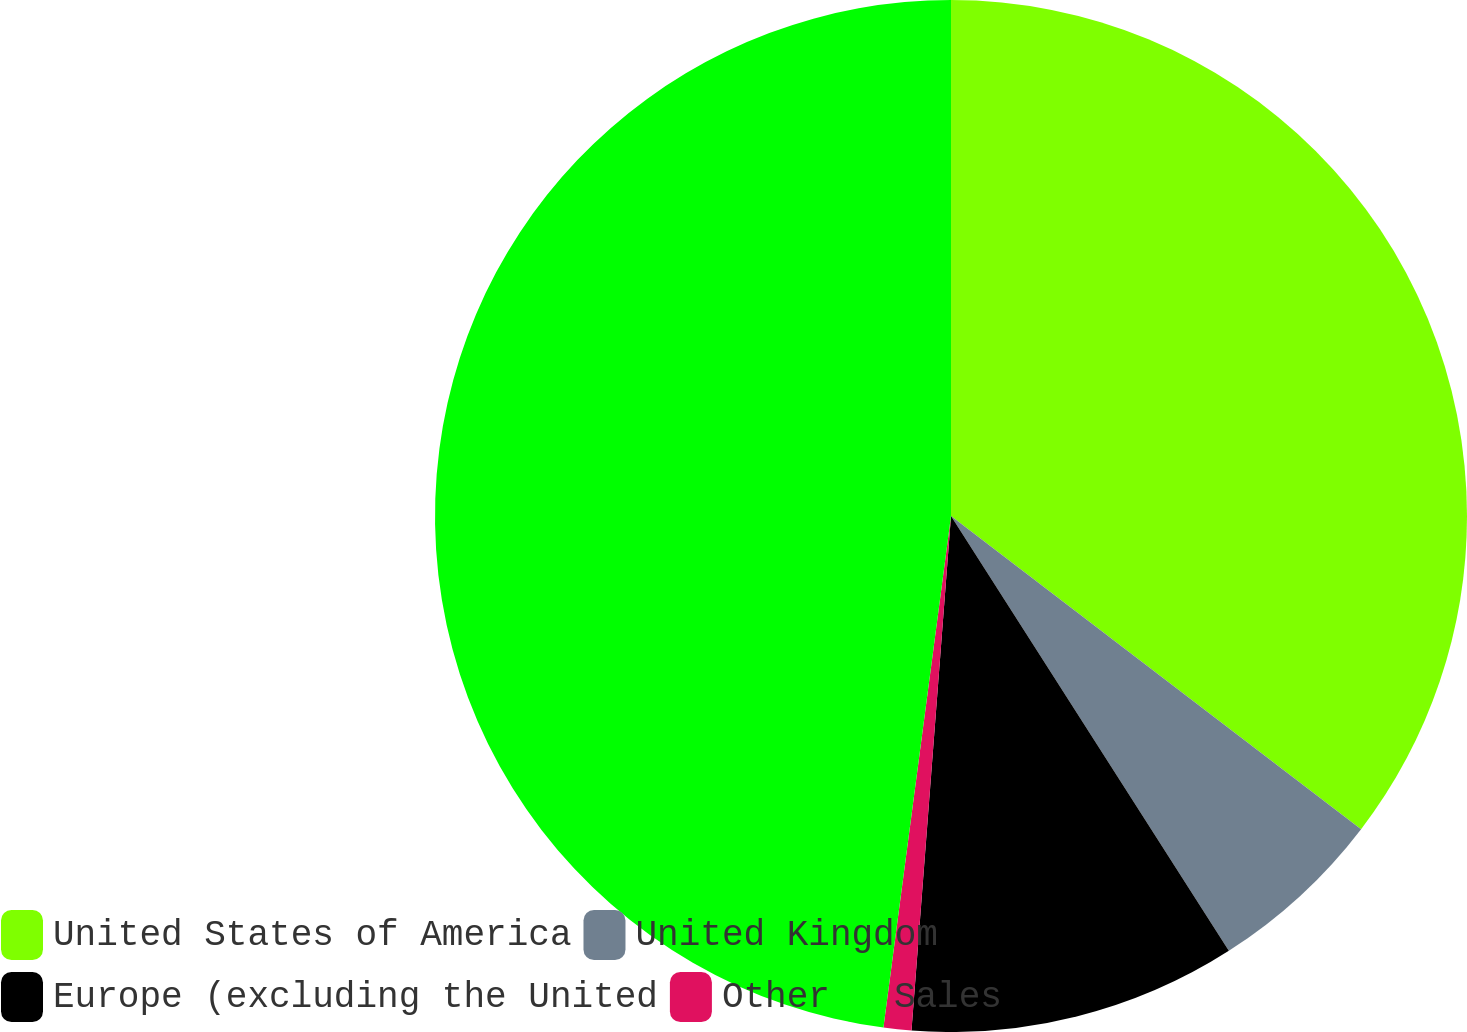<chart> <loc_0><loc_0><loc_500><loc_500><pie_chart><fcel>United States of America<fcel>United Kingdom<fcel>Europe (excluding the United<fcel>Other<fcel>Sales<nl><fcel>35.38%<fcel>5.57%<fcel>10.27%<fcel>0.87%<fcel>47.91%<nl></chart> 